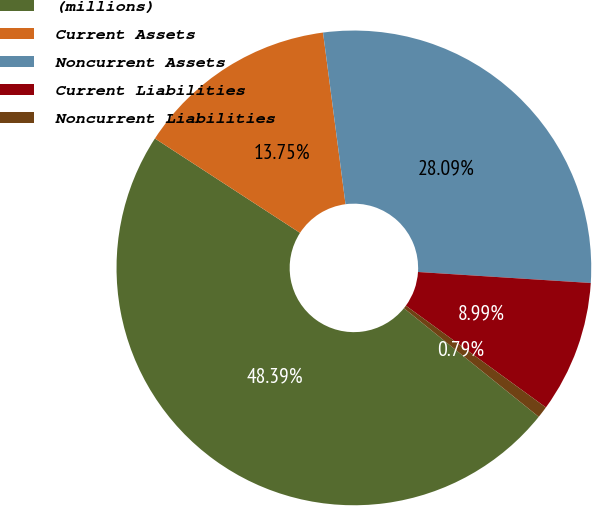Convert chart to OTSL. <chart><loc_0><loc_0><loc_500><loc_500><pie_chart><fcel>(millions)<fcel>Current Assets<fcel>Noncurrent Assets<fcel>Current Liabilities<fcel>Noncurrent Liabilities<nl><fcel>48.39%<fcel>13.75%<fcel>28.09%<fcel>8.99%<fcel>0.79%<nl></chart> 